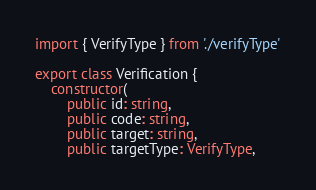<code> <loc_0><loc_0><loc_500><loc_500><_TypeScript_>import { VerifyType } from './verifyType'

export class Verification {
    constructor(
        public id: string,
        public code: string,
        public target: string,
        public targetType: VerifyType,</code> 